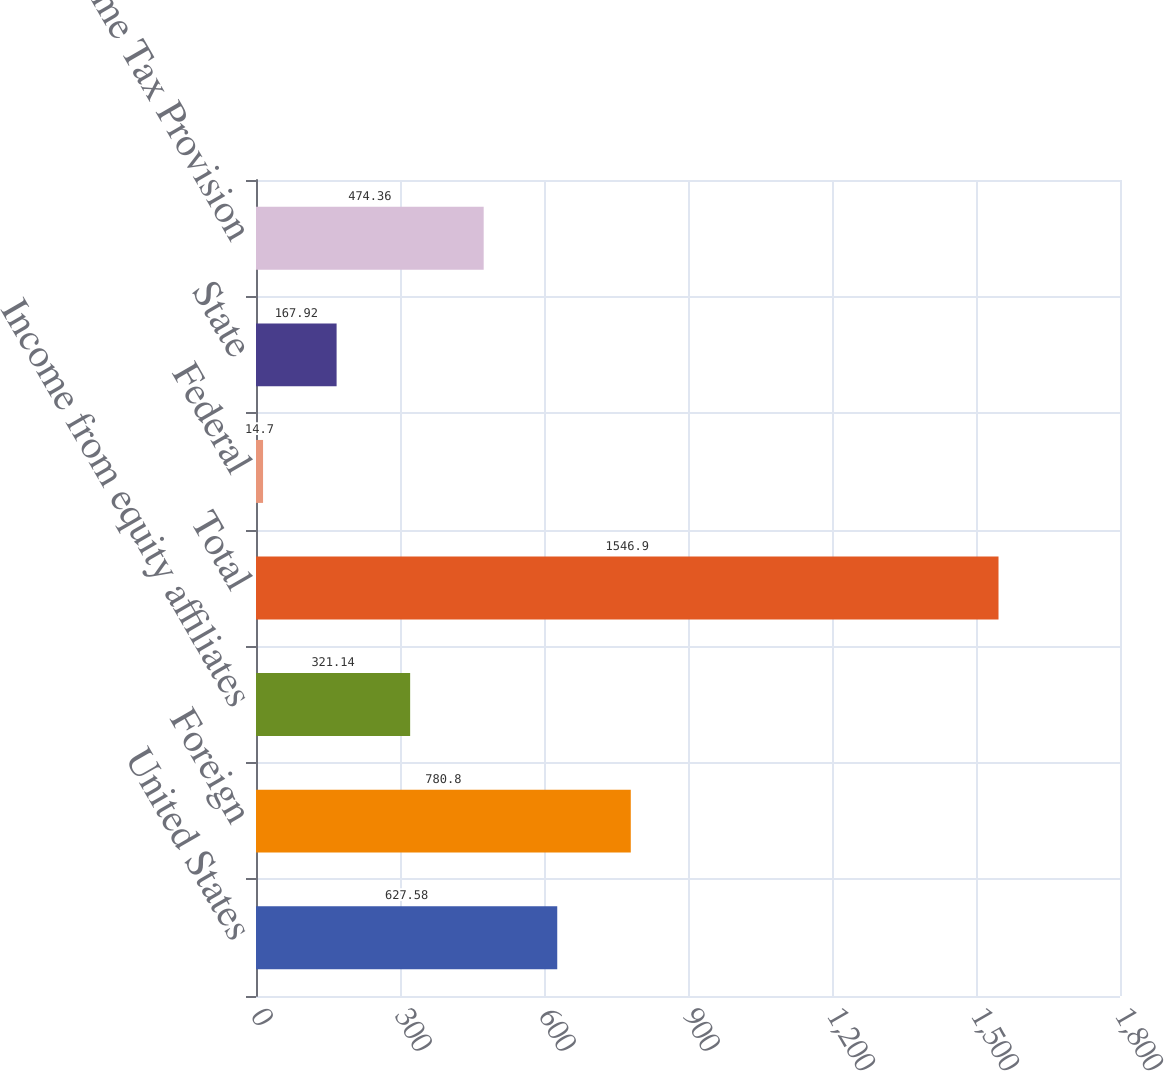<chart> <loc_0><loc_0><loc_500><loc_500><bar_chart><fcel>United States<fcel>Foreign<fcel>Income from equity affiliates<fcel>Total<fcel>Federal<fcel>State<fcel>Income Tax Provision<nl><fcel>627.58<fcel>780.8<fcel>321.14<fcel>1546.9<fcel>14.7<fcel>167.92<fcel>474.36<nl></chart> 